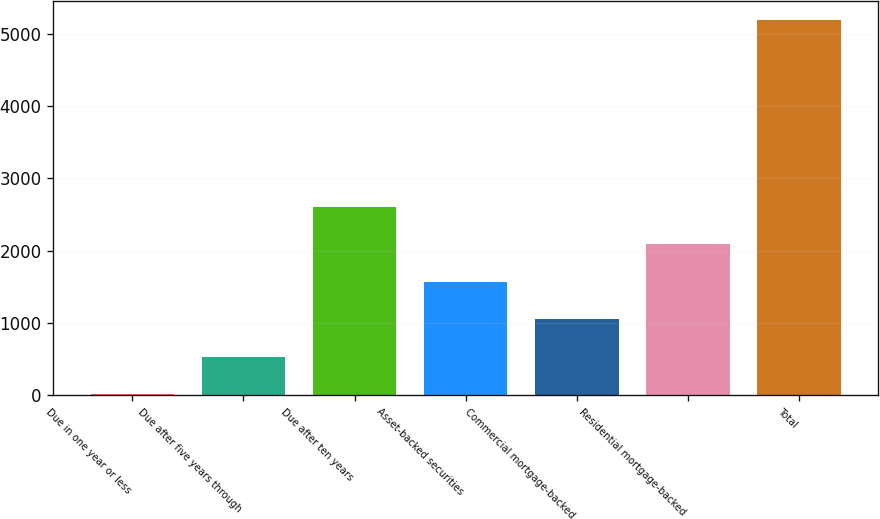Convert chart. <chart><loc_0><loc_0><loc_500><loc_500><bar_chart><fcel>Due in one year or less<fcel>Due after five years through<fcel>Due after ten years<fcel>Asset-backed securities<fcel>Commercial mortgage-backed<fcel>Residential mortgage-backed<fcel>Total<nl><fcel>10<fcel>528.7<fcel>2603.5<fcel>1566.1<fcel>1047.4<fcel>2084.8<fcel>5197<nl></chart> 